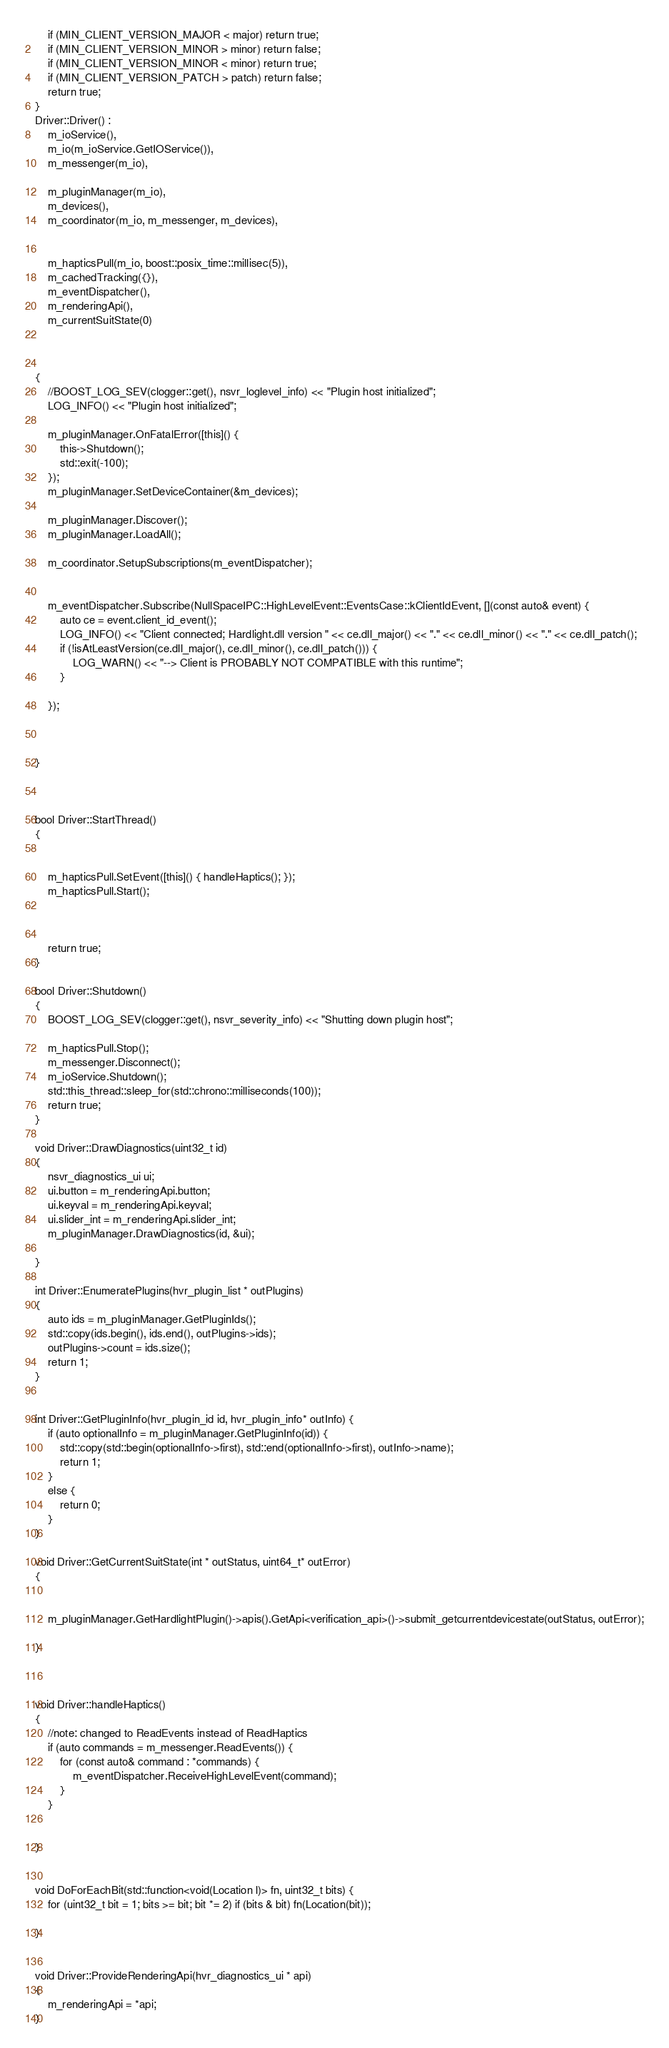<code> <loc_0><loc_0><loc_500><loc_500><_C++_>	if (MIN_CLIENT_VERSION_MAJOR < major) return true;
	if (MIN_CLIENT_VERSION_MINOR > minor) return false;
	if (MIN_CLIENT_VERSION_MINOR < minor) return true;
	if (MIN_CLIENT_VERSION_PATCH > patch) return false;
	return true;
}
Driver::Driver() :
	m_ioService(),
	m_io(m_ioService.GetIOService()),
	m_messenger(m_io),

	m_pluginManager(m_io),
	m_devices(),
	m_coordinator(m_io, m_messenger, m_devices),


	m_hapticsPull(m_io, boost::posix_time::millisec(5)),
	m_cachedTracking({}),
	m_eventDispatcher(),
	m_renderingApi(),
	m_currentSuitState(0)



{
	//BOOST_LOG_SEV(clogger::get(), nsvr_loglevel_info) << "Plugin host initialized";
	LOG_INFO() << "Plugin host initialized";

	m_pluginManager.OnFatalError([this]() {
		this->Shutdown();
		std::exit(-100);
	});
	m_pluginManager.SetDeviceContainer(&m_devices);

	m_pluginManager.Discover();
	m_pluginManager.LoadAll();

	m_coordinator.SetupSubscriptions(m_eventDispatcher);


	m_eventDispatcher.Subscribe(NullSpaceIPC::HighLevelEvent::EventsCase::kClientIdEvent, [](const auto& event) {
		auto ce = event.client_id_event();
		LOG_INFO() << "Client connected; Hardlight.dll version " << ce.dll_major() << "." << ce.dll_minor() << "." << ce.dll_patch();
		if (!isAtLeastVersion(ce.dll_major(), ce.dll_minor(), ce.dll_patch())) {
			LOG_WARN() << "--> Client is PROBABLY NOT COMPATIBLE with this runtime";
		}
	
	});


	
}



bool Driver::StartThread()
{
	

	m_hapticsPull.SetEvent([this]() { handleHaptics(); });
	m_hapticsPull.Start();

	

	return true;
}

bool Driver::Shutdown()
{
	BOOST_LOG_SEV(clogger::get(), nsvr_severity_info) << "Shutting down plugin host";

	m_hapticsPull.Stop();
	m_messenger.Disconnect();
	m_ioService.Shutdown();
	std::this_thread::sleep_for(std::chrono::milliseconds(100));
	return true;
}

void Driver::DrawDiagnostics(uint32_t id)
{
	nsvr_diagnostics_ui ui;
	ui.button = m_renderingApi.button;
	ui.keyval = m_renderingApi.keyval;
	ui.slider_int = m_renderingApi.slider_int;
	m_pluginManager.DrawDiagnostics(id, &ui);

}

int Driver::EnumeratePlugins(hvr_plugin_list * outPlugins)
{
	auto ids = m_pluginManager.GetPluginIds();
	std::copy(ids.begin(), ids.end(), outPlugins->ids);
	outPlugins->count = ids.size();
	return 1;
}


int Driver::GetPluginInfo(hvr_plugin_id id, hvr_plugin_info* outInfo) {
	if (auto optionalInfo = m_pluginManager.GetPluginInfo(id)) {
		std::copy(std::begin(optionalInfo->first), std::end(optionalInfo->first), outInfo->name);
		return 1;
	}
	else {
		return 0;
	}
}

void Driver::GetCurrentSuitState(int * outStatus, uint64_t* outError)
{
	
	
	m_pluginManager.GetHardlightPlugin()->apis().GetApi<verification_api>()->submit_getcurrentdevicestate(outStatus, outError);

}



void Driver::handleHaptics()
{
	//note: changed to ReadEvents instead of ReadHaptics
	if (auto commands = m_messenger.ReadEvents()) {
		for (const auto& command : *commands) {
			m_eventDispatcher.ReceiveHighLevelEvent(command);
		}
	}

	
}


void DoForEachBit(std::function<void(Location l)> fn, uint32_t bits) {
	for (uint32_t bit = 1; bits >= bit; bit *= 2) if (bits & bit) fn(Location(bit));

}


void Driver::ProvideRenderingApi(hvr_diagnostics_ui * api)
{
	m_renderingApi = *api;
}

</code> 